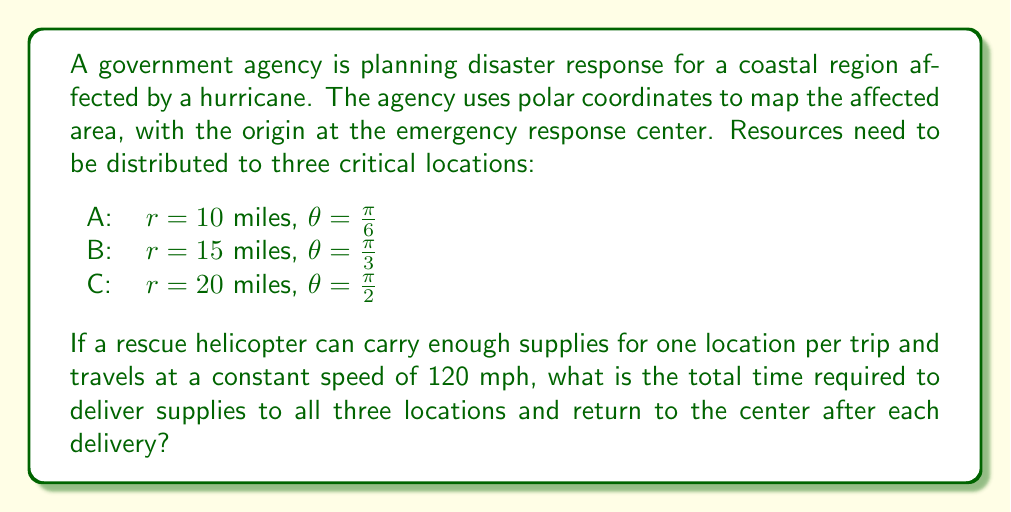Solve this math problem. To solve this problem, we need to calculate the total distance traveled by the helicopter and then determine the time based on its speed. Let's break it down step-by-step:

1) First, we need to calculate the distance to each location and back:

   For A: $2 \cdot 10 = 20$ miles
   For B: $2 \cdot 15 = 30$ miles
   For C: $2 \cdot 20 = 40$ miles

2) The total distance traveled is the sum of these round trips:

   Total distance = $20 + 30 + 40 = 90$ miles

3) Now, we can calculate the time using the formula:

   $\text{Time} = \frac{\text{Distance}}{\text{Speed}}$

   $\text{Time} = \frac{90 \text{ miles}}{120 \text{ miles/hour}}$

4) Simplifying:

   $\text{Time} = \frac{3}{4} \text{ hours} = 0.75 \text{ hours}$

5) Converting to minutes:

   $0.75 \text{ hours} \cdot 60 \text{ minutes/hour} = 45 \text{ minutes}$

Therefore, the total time required to deliver supplies to all three locations and return to the center after each delivery is 45 minutes.
Answer: 45 minutes 